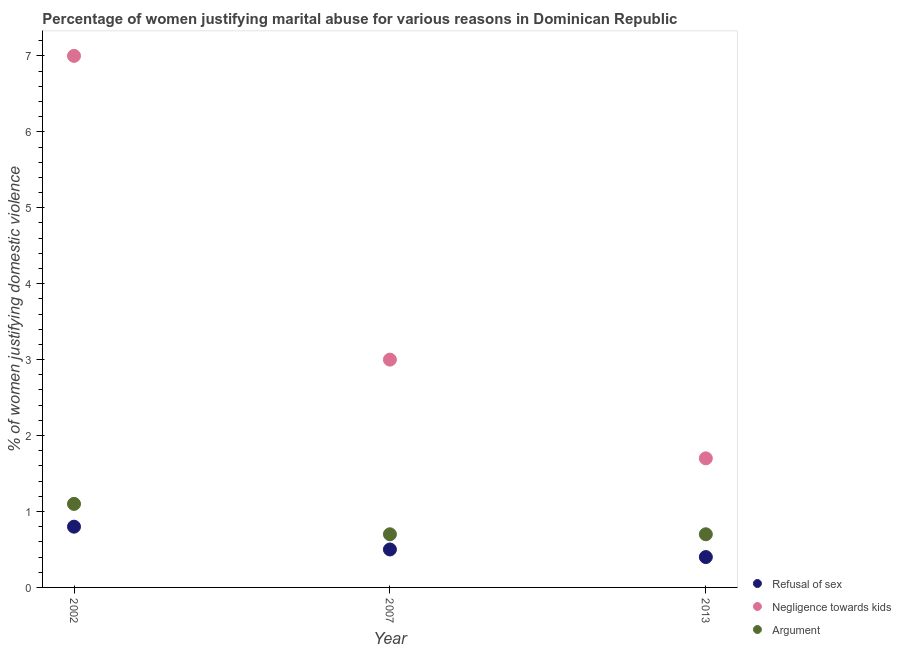How many different coloured dotlines are there?
Your answer should be very brief. 3. What is the percentage of women justifying domestic violence due to refusal of sex in 2002?
Your response must be concise. 0.8. Across all years, what is the maximum percentage of women justifying domestic violence due to arguments?
Your response must be concise. 1.1. Across all years, what is the minimum percentage of women justifying domestic violence due to refusal of sex?
Your response must be concise. 0.4. In which year was the percentage of women justifying domestic violence due to arguments minimum?
Ensure brevity in your answer.  2007. What is the total percentage of women justifying domestic violence due to arguments in the graph?
Give a very brief answer. 2.5. What is the difference between the percentage of women justifying domestic violence due to arguments in 2013 and the percentage of women justifying domestic violence due to negligence towards kids in 2002?
Offer a very short reply. -6.3. What is the average percentage of women justifying domestic violence due to refusal of sex per year?
Keep it short and to the point. 0.57. In the year 2013, what is the difference between the percentage of women justifying domestic violence due to negligence towards kids and percentage of women justifying domestic violence due to refusal of sex?
Your answer should be very brief. 1.3. What is the ratio of the percentage of women justifying domestic violence due to arguments in 2002 to that in 2013?
Your answer should be compact. 1.57. What is the difference between the highest and the second highest percentage of women justifying domestic violence due to refusal of sex?
Your answer should be compact. 0.3. What is the difference between the highest and the lowest percentage of women justifying domestic violence due to refusal of sex?
Your answer should be very brief. 0.4. In how many years, is the percentage of women justifying domestic violence due to negligence towards kids greater than the average percentage of women justifying domestic violence due to negligence towards kids taken over all years?
Provide a succinct answer. 1. Is the sum of the percentage of women justifying domestic violence due to negligence towards kids in 2007 and 2013 greater than the maximum percentage of women justifying domestic violence due to refusal of sex across all years?
Your answer should be very brief. Yes. Does the percentage of women justifying domestic violence due to negligence towards kids monotonically increase over the years?
Offer a terse response. No. Is the percentage of women justifying domestic violence due to refusal of sex strictly greater than the percentage of women justifying domestic violence due to negligence towards kids over the years?
Make the answer very short. No. How many dotlines are there?
Provide a succinct answer. 3. What is the difference between two consecutive major ticks on the Y-axis?
Provide a short and direct response. 1. Where does the legend appear in the graph?
Your answer should be compact. Bottom right. How are the legend labels stacked?
Your response must be concise. Vertical. What is the title of the graph?
Offer a terse response. Percentage of women justifying marital abuse for various reasons in Dominican Republic. What is the label or title of the X-axis?
Provide a succinct answer. Year. What is the label or title of the Y-axis?
Provide a short and direct response. % of women justifying domestic violence. What is the % of women justifying domestic violence in Refusal of sex in 2002?
Keep it short and to the point. 0.8. What is the % of women justifying domestic violence of Negligence towards kids in 2002?
Offer a very short reply. 7. What is the % of women justifying domestic violence of Argument in 2002?
Make the answer very short. 1.1. What is the % of women justifying domestic violence in Negligence towards kids in 2013?
Provide a short and direct response. 1.7. What is the % of women justifying domestic violence in Argument in 2013?
Make the answer very short. 0.7. Across all years, what is the minimum % of women justifying domestic violence of Refusal of sex?
Your answer should be compact. 0.4. What is the total % of women justifying domestic violence in Refusal of sex in the graph?
Your response must be concise. 1.7. What is the total % of women justifying domestic violence in Argument in the graph?
Your response must be concise. 2.5. What is the difference between the % of women justifying domestic violence in Refusal of sex in 2002 and that in 2007?
Your answer should be very brief. 0.3. What is the difference between the % of women justifying domestic violence in Refusal of sex in 2002 and that in 2013?
Your answer should be very brief. 0.4. What is the difference between the % of women justifying domestic violence of Argument in 2007 and that in 2013?
Your answer should be very brief. 0. What is the difference between the % of women justifying domestic violence of Refusal of sex in 2002 and the % of women justifying domestic violence of Negligence towards kids in 2007?
Provide a short and direct response. -2.2. What is the difference between the % of women justifying domestic violence in Refusal of sex in 2002 and the % of women justifying domestic violence in Argument in 2007?
Ensure brevity in your answer.  0.1. What is the difference between the % of women justifying domestic violence of Refusal of sex in 2002 and the % of women justifying domestic violence of Negligence towards kids in 2013?
Provide a succinct answer. -0.9. What is the difference between the % of women justifying domestic violence of Refusal of sex in 2002 and the % of women justifying domestic violence of Argument in 2013?
Ensure brevity in your answer.  0.1. What is the difference between the % of women justifying domestic violence of Refusal of sex in 2007 and the % of women justifying domestic violence of Argument in 2013?
Offer a terse response. -0.2. What is the difference between the % of women justifying domestic violence in Negligence towards kids in 2007 and the % of women justifying domestic violence in Argument in 2013?
Your response must be concise. 2.3. What is the average % of women justifying domestic violence in Refusal of sex per year?
Offer a terse response. 0.57. In the year 2002, what is the difference between the % of women justifying domestic violence of Refusal of sex and % of women justifying domestic violence of Negligence towards kids?
Provide a short and direct response. -6.2. In the year 2002, what is the difference between the % of women justifying domestic violence of Negligence towards kids and % of women justifying domestic violence of Argument?
Keep it short and to the point. 5.9. In the year 2007, what is the difference between the % of women justifying domestic violence of Refusal of sex and % of women justifying domestic violence of Negligence towards kids?
Offer a very short reply. -2.5. In the year 2007, what is the difference between the % of women justifying domestic violence in Refusal of sex and % of women justifying domestic violence in Argument?
Ensure brevity in your answer.  -0.2. In the year 2007, what is the difference between the % of women justifying domestic violence in Negligence towards kids and % of women justifying domestic violence in Argument?
Ensure brevity in your answer.  2.3. In the year 2013, what is the difference between the % of women justifying domestic violence in Refusal of sex and % of women justifying domestic violence in Argument?
Your response must be concise. -0.3. What is the ratio of the % of women justifying domestic violence of Negligence towards kids in 2002 to that in 2007?
Ensure brevity in your answer.  2.33. What is the ratio of the % of women justifying domestic violence in Argument in 2002 to that in 2007?
Offer a very short reply. 1.57. What is the ratio of the % of women justifying domestic violence of Refusal of sex in 2002 to that in 2013?
Make the answer very short. 2. What is the ratio of the % of women justifying domestic violence of Negligence towards kids in 2002 to that in 2013?
Make the answer very short. 4.12. What is the ratio of the % of women justifying domestic violence in Argument in 2002 to that in 2013?
Ensure brevity in your answer.  1.57. What is the ratio of the % of women justifying domestic violence in Negligence towards kids in 2007 to that in 2013?
Your answer should be very brief. 1.76. What is the difference between the highest and the lowest % of women justifying domestic violence in Negligence towards kids?
Your answer should be compact. 5.3. What is the difference between the highest and the lowest % of women justifying domestic violence in Argument?
Offer a very short reply. 0.4. 